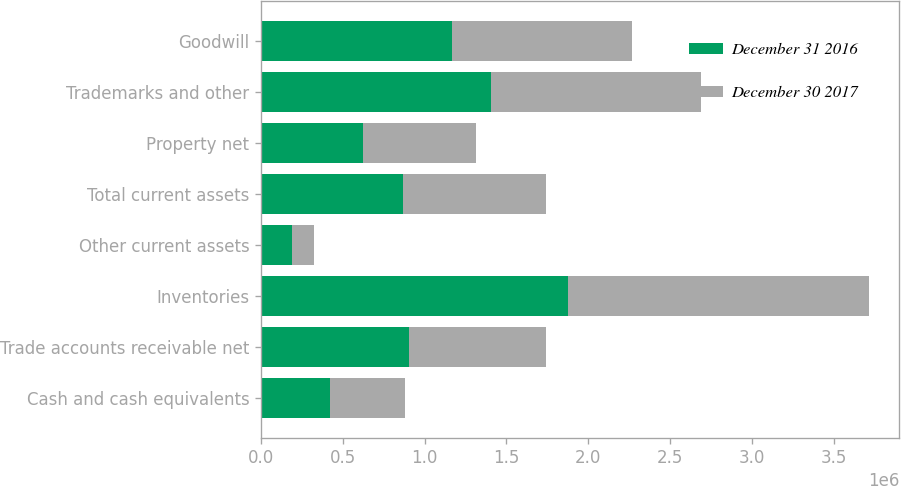Convert chart to OTSL. <chart><loc_0><loc_0><loc_500><loc_500><stacked_bar_chart><ecel><fcel>Cash and cash equivalents<fcel>Trade accounts receivable net<fcel>Inventories<fcel>Other current assets<fcel>Total current assets<fcel>Property net<fcel>Trademarks and other<fcel>Goodwill<nl><fcel>December 31 2016<fcel>421566<fcel>903318<fcel>1.87499e+06<fcel>186496<fcel>870121<fcel>623991<fcel>1.40286e+06<fcel>1.16701e+06<nl><fcel>December 30 2017<fcel>460245<fcel>836924<fcel>1.84056e+06<fcel>137535<fcel>870121<fcel>692464<fcel>1.28546e+06<fcel>1.09854e+06<nl></chart> 